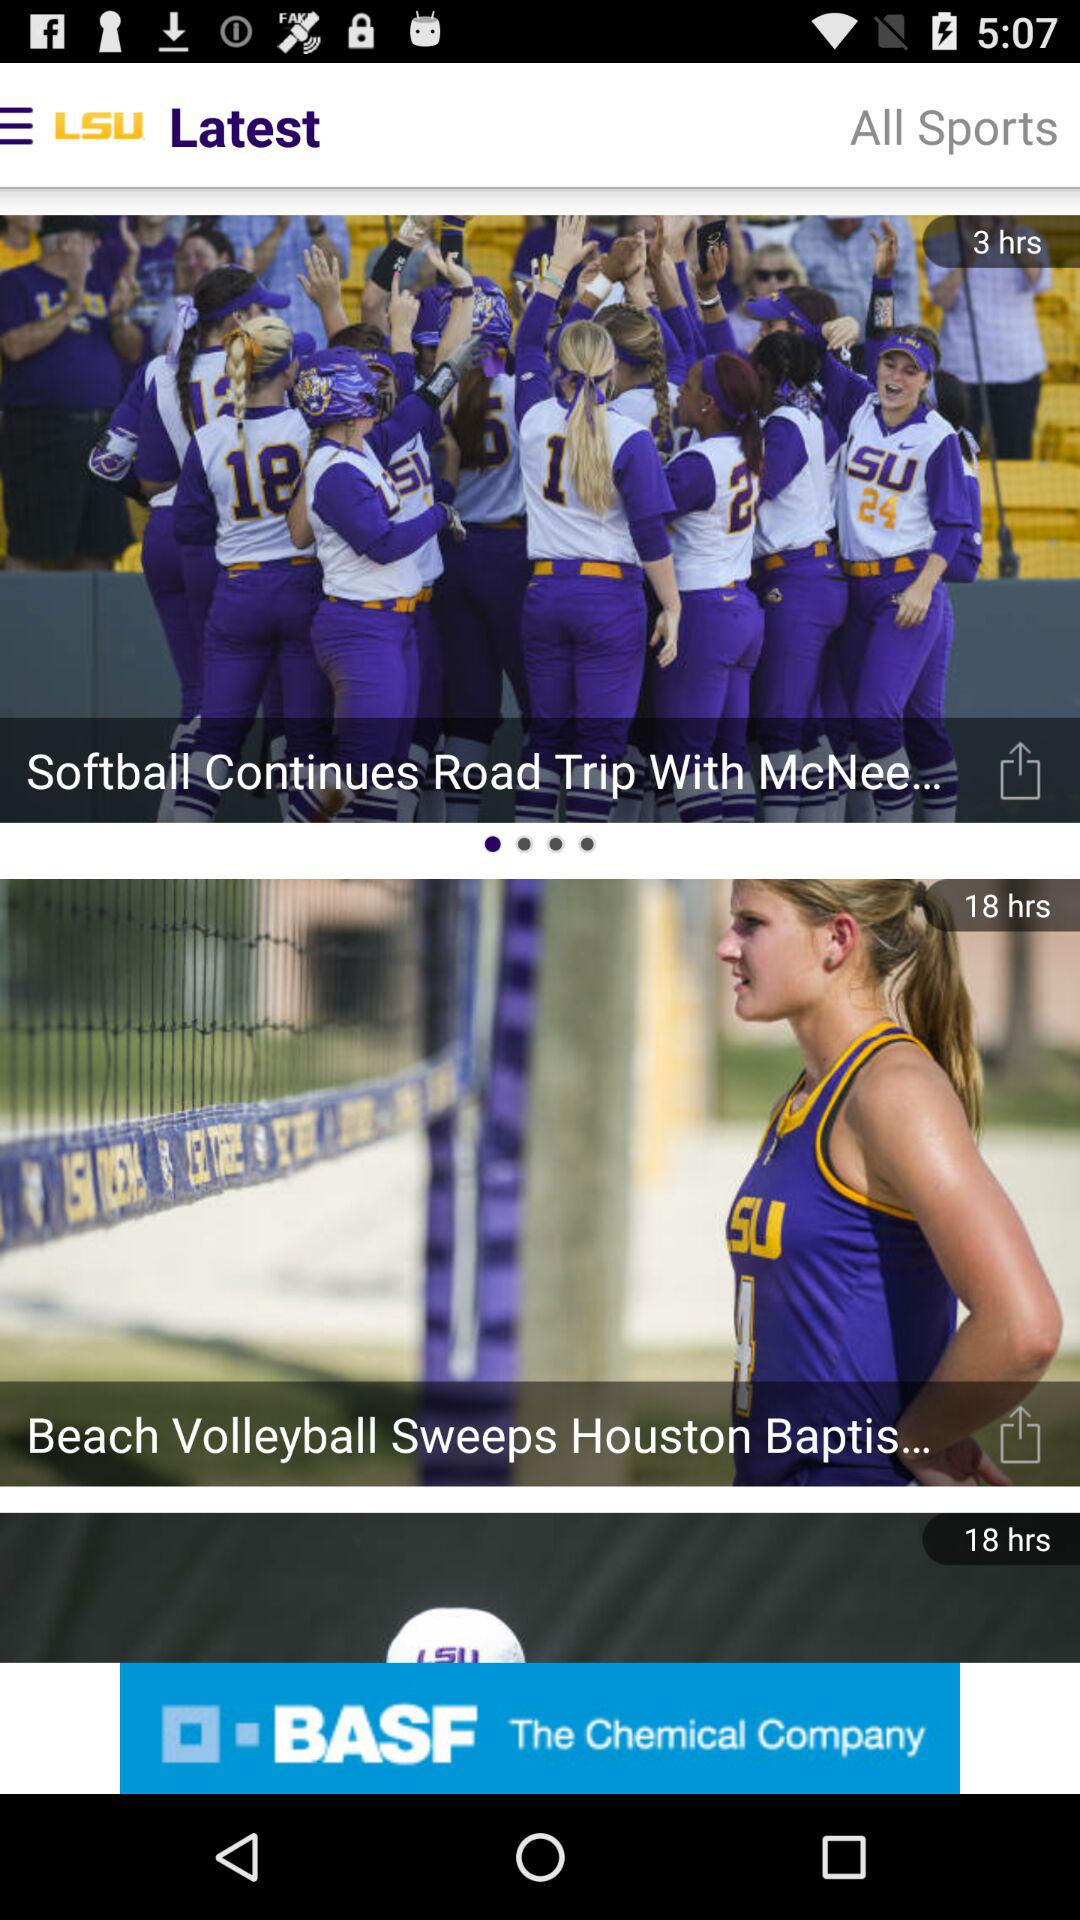How many hours ago was the oldest item posted?
Answer the question using a single word or phrase. 18 